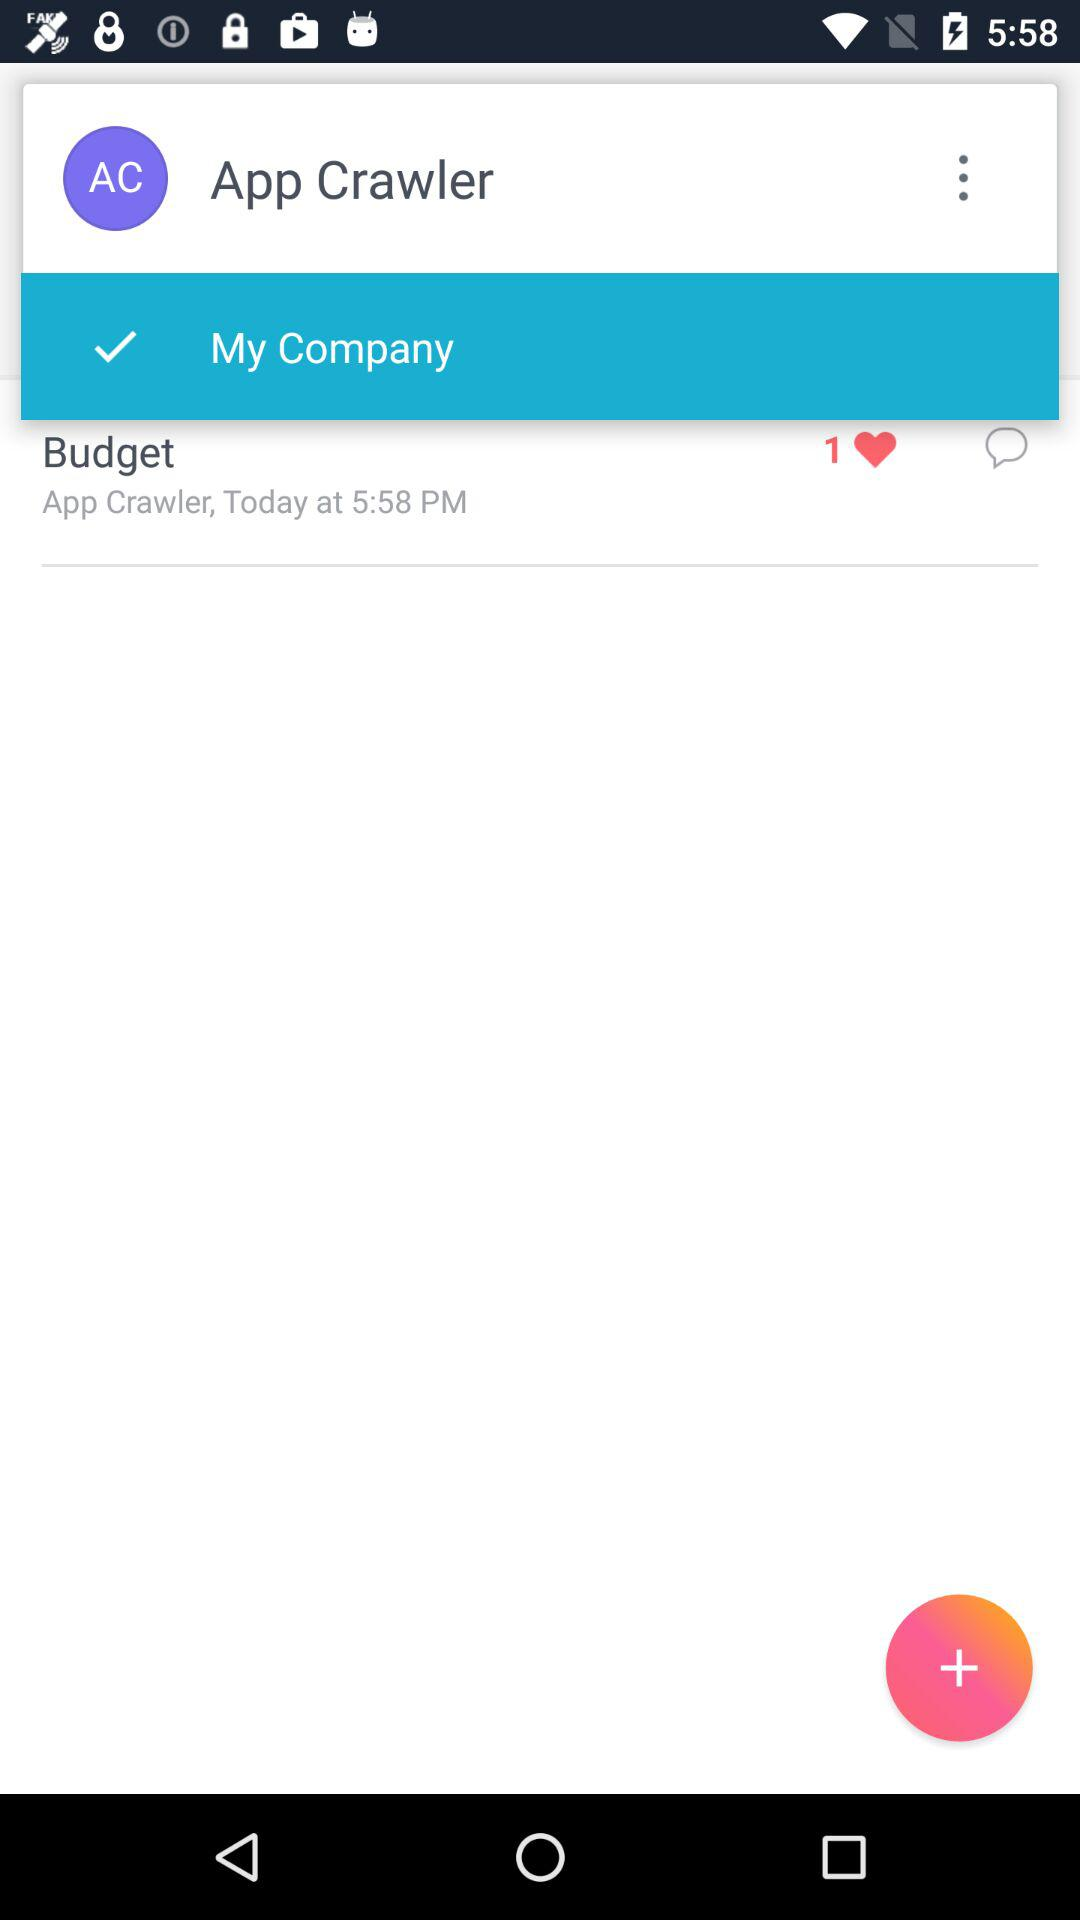What's the user name? The user name is App Crawler. 